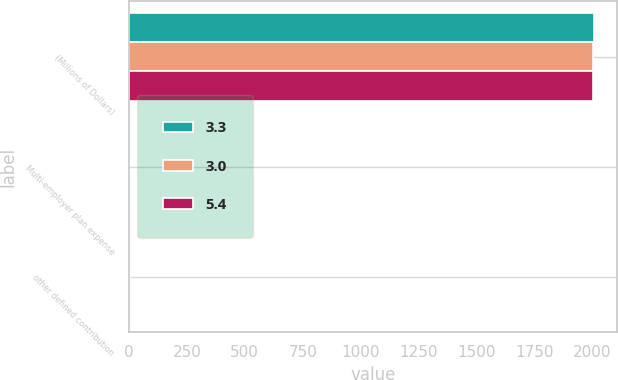Convert chart to OTSL. <chart><loc_0><loc_0><loc_500><loc_500><stacked_bar_chart><ecel><fcel>(Millions of Dollars)<fcel>Multi-employer plan expense<fcel>other defined contribution<nl><fcel>3.3<fcel>2006<fcel>0.8<fcel>5.4<nl><fcel>3<fcel>2005<fcel>0.7<fcel>3.3<nl><fcel>5.4<fcel>2004<fcel>0.4<fcel>3<nl></chart> 